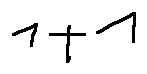<formula> <loc_0><loc_0><loc_500><loc_500>1 + 1</formula> 